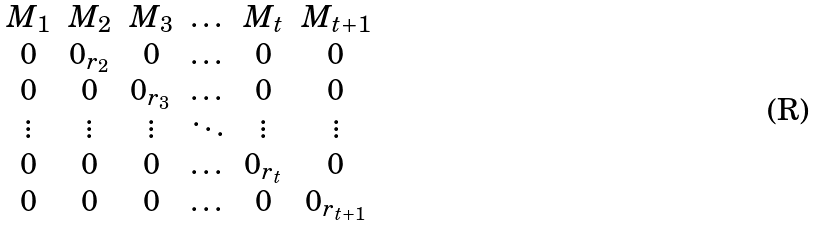<formula> <loc_0><loc_0><loc_500><loc_500>\begin{matrix} M _ { 1 } & M _ { 2 } & M _ { 3 } & \dots & M _ { t } & M _ { t + 1 } \\ 0 & 0 _ { r _ { 2 } } & 0 & \dots & 0 & 0 \\ 0 & 0 & 0 _ { r _ { 3 } } & \dots & 0 & 0 \\ \vdots & \vdots & \vdots & \ddots & \vdots & \vdots \\ 0 & 0 & 0 & \dots & 0 _ { r _ { t } } & 0 \\ 0 & 0 & 0 & \dots & 0 & 0 _ { r _ { t + 1 } } \\ \end{matrix}</formula> 